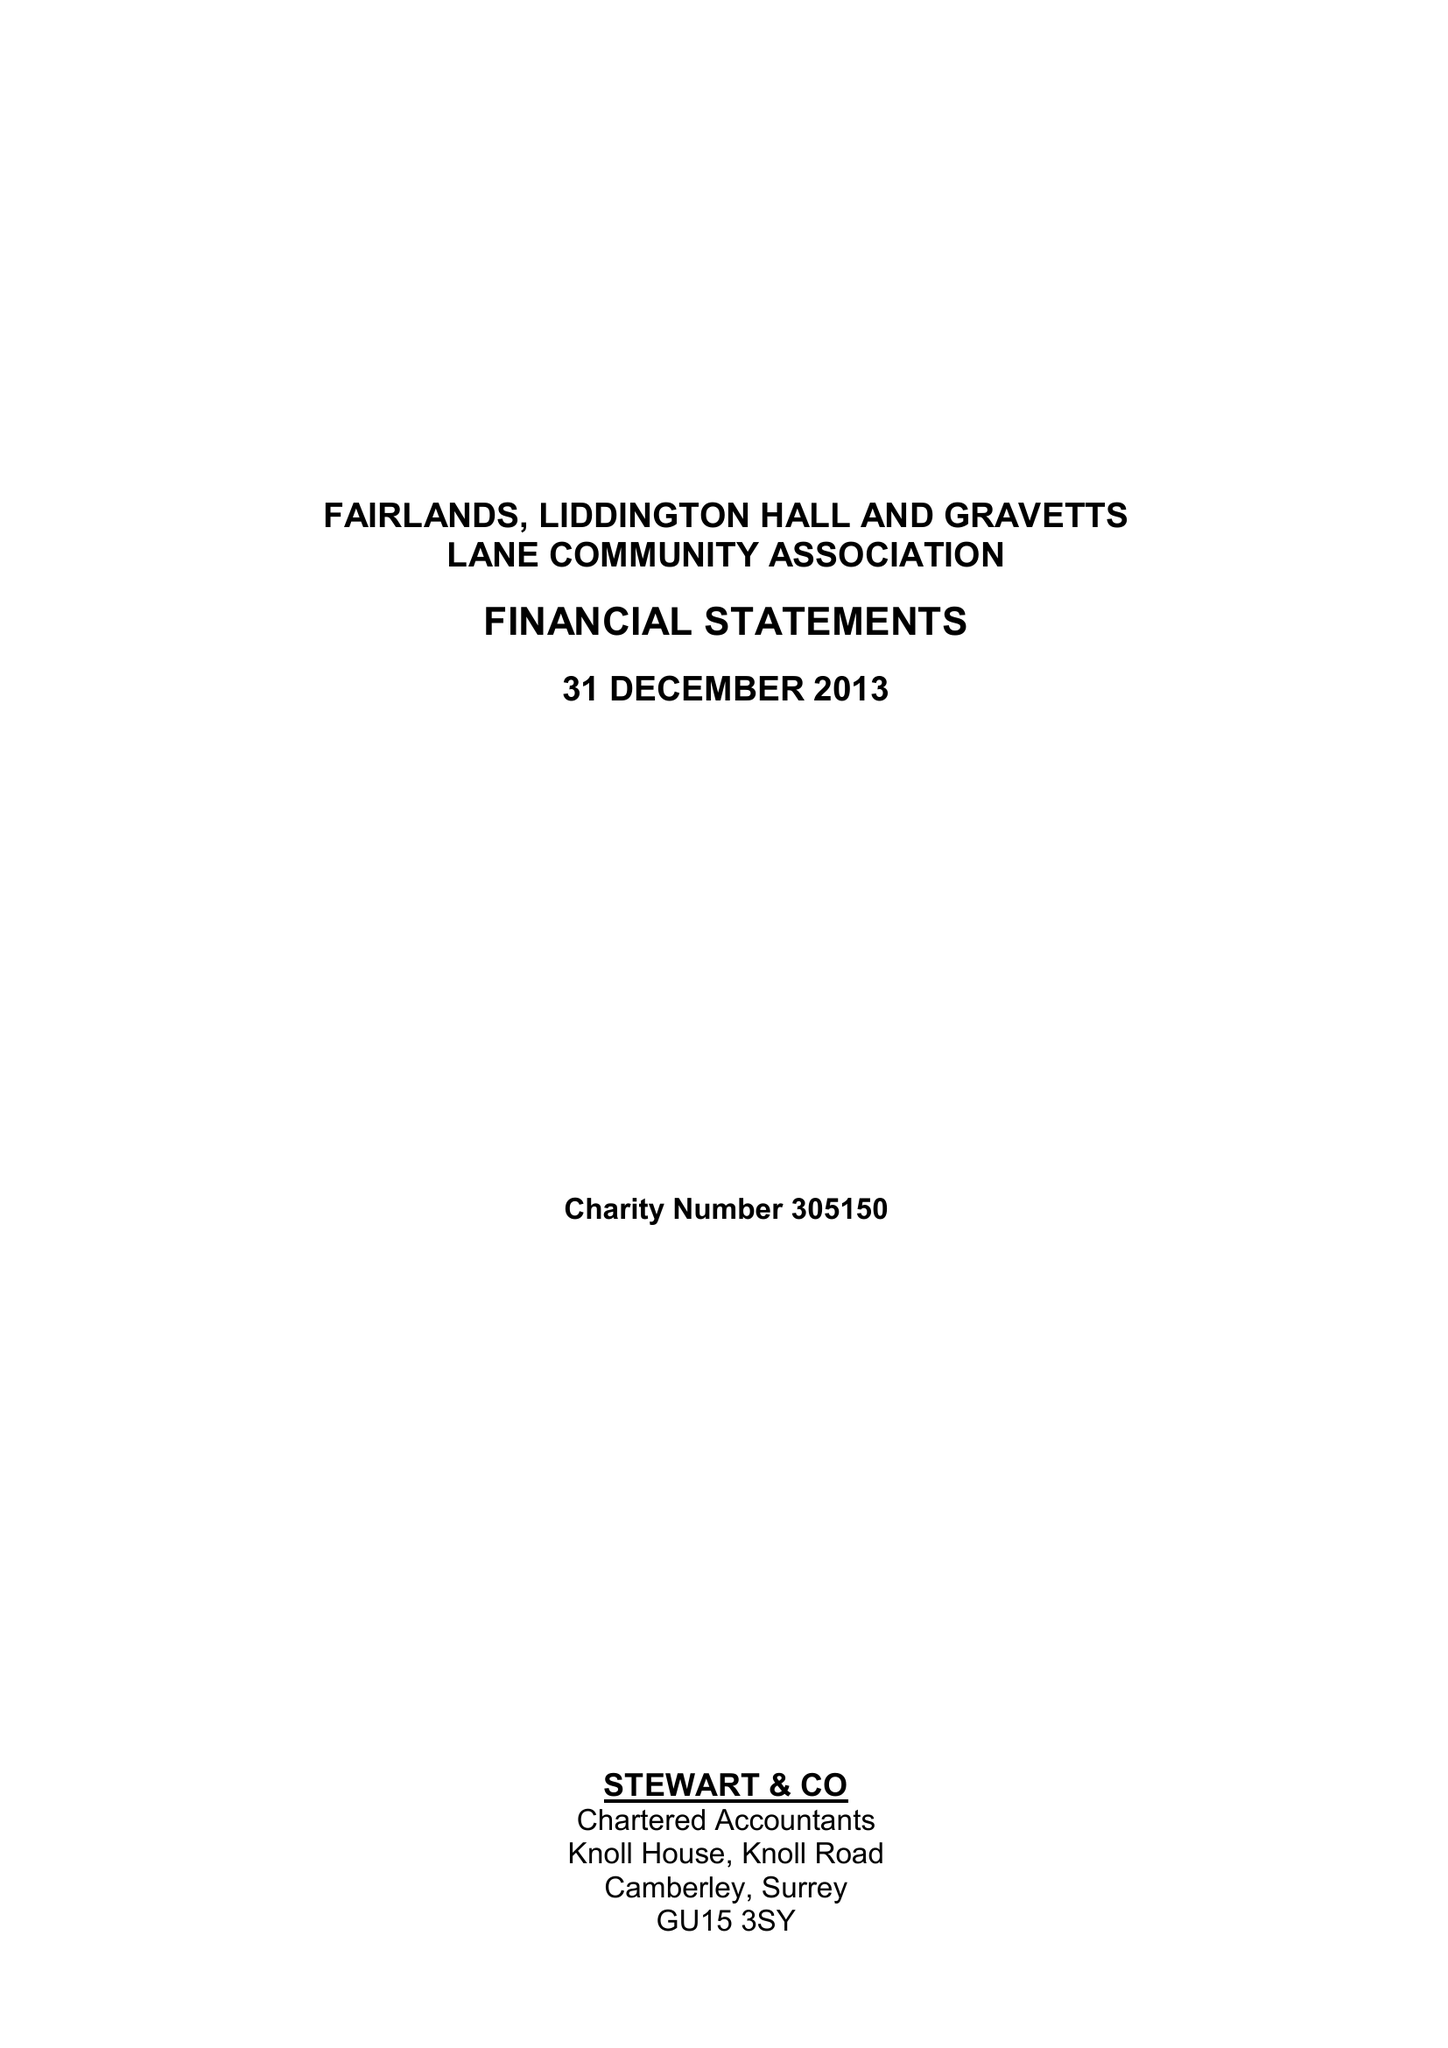What is the value for the report_date?
Answer the question using a single word or phrase. 2013-12-31 